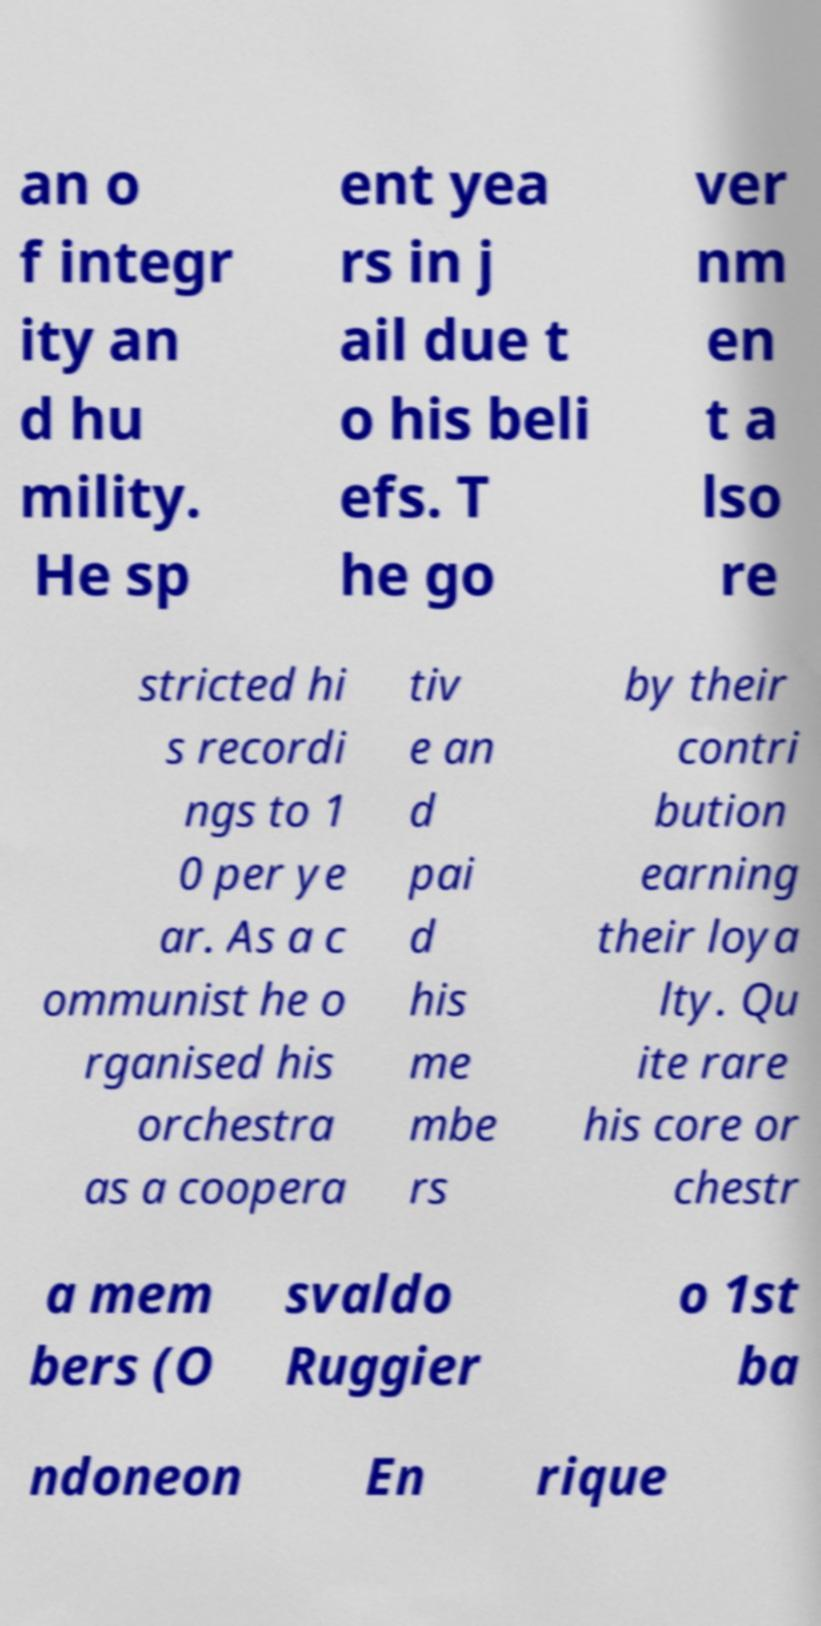Please read and relay the text visible in this image. What does it say? an o f integr ity an d hu mility. He sp ent yea rs in j ail due t o his beli efs. T he go ver nm en t a lso re stricted hi s recordi ngs to 1 0 per ye ar. As a c ommunist he o rganised his orchestra as a coopera tiv e an d pai d his me mbe rs by their contri bution earning their loya lty. Qu ite rare his core or chestr a mem bers (O svaldo Ruggier o 1st ba ndoneon En rique 